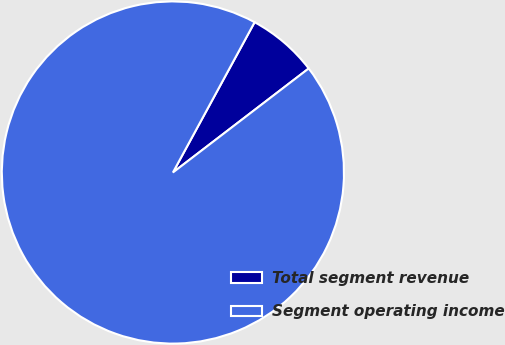<chart> <loc_0><loc_0><loc_500><loc_500><pie_chart><fcel>Total segment revenue<fcel>Segment operating income<nl><fcel>6.67%<fcel>93.33%<nl></chart> 